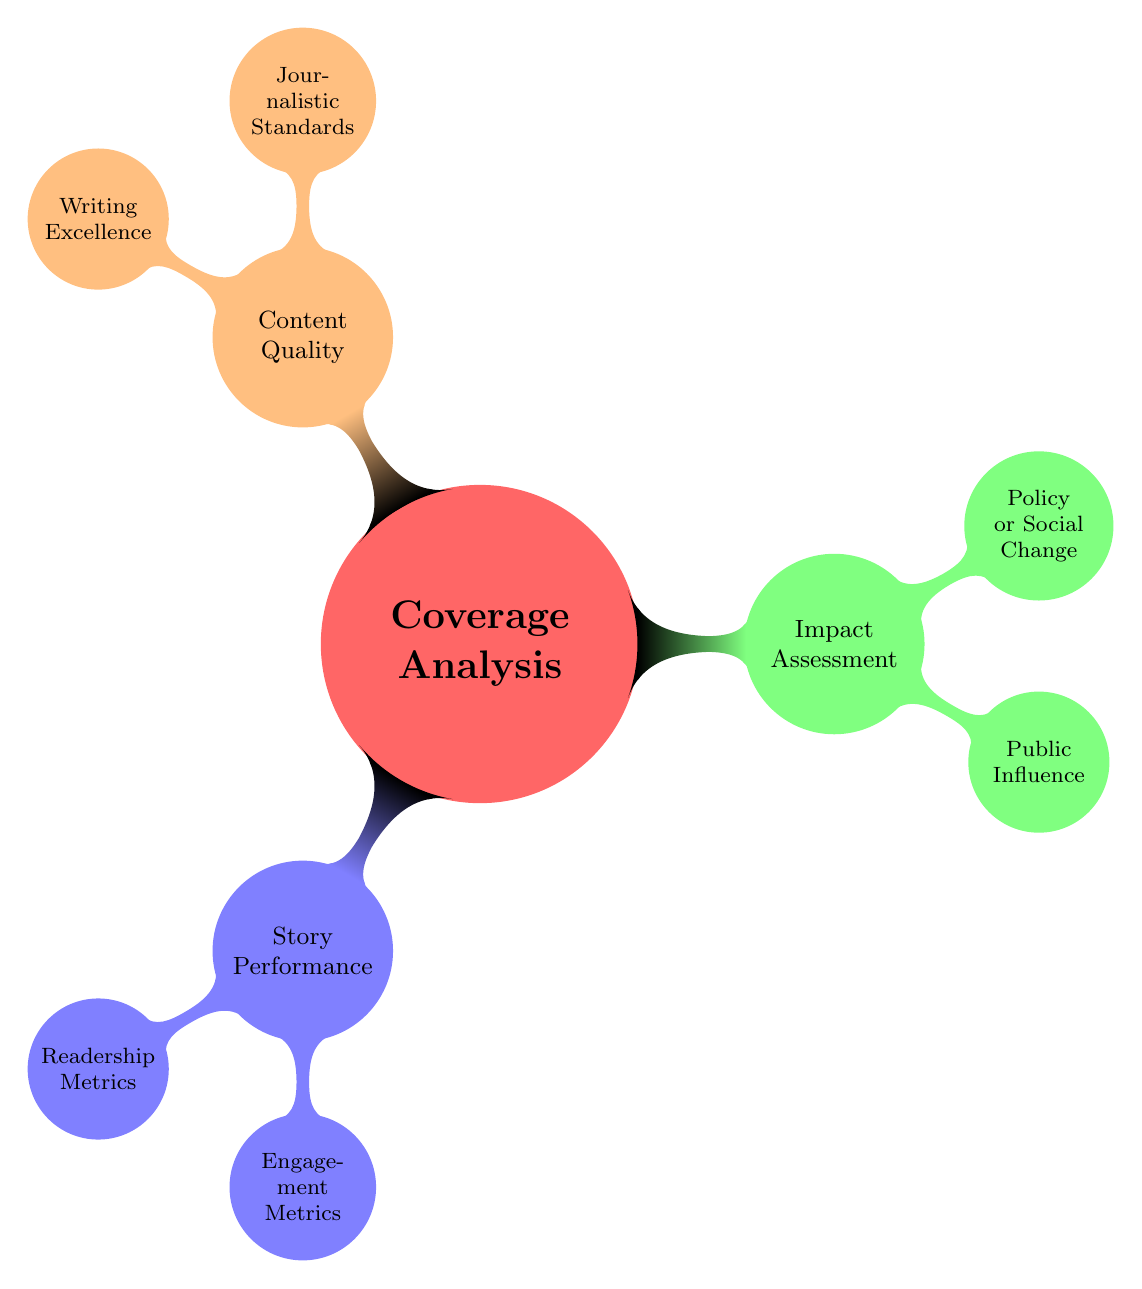What are the three main categories in the Coverage Analysis? The main categories are Story Performance, Impact Assessment, and Content Quality, which are the first level nodes branching from the Coverage Analysis node.
Answer: Story Performance, Impact Assessment, Content Quality How many nodes are under the Story Performance category? The Story Performance category has two child nodes: Readership Metrics and Engagement Metrics, making a total of two nodes under this category.
Answer: 2 What type of metrics are included in the Readership Metrics? The Readership Metrics include Page Views, Time on Page, and Bounce Rate, which are the specific metrics outlined under this category.
Answer: Page Views, Time on Page, Bounce Rate Which metrics are used to evaluate Social Shares? Social shares are evaluated using Facebook Insights and Twitter Analytics as indicated in the Engagement Metrics section of the diagram.
Answer: Facebook Insights, Twitter Analytics How does the Impact Assessment relate to Public Influence? The Impact Assessment contains a category called Public Influence, which explores metrics such as Mentions in Other Media and Citations in Research or Reports, indicating a direct relationship between them.
Answer: Public Influence includes Mentions in Other Media and Citations in Research or Reports What is the second level node under Content Quality? The second level nodes under Content Quality are Journalistic Standards and Writing Excellence, showing the aspects considered under content evaluation.
Answer: Journalistic Standards, Writing Excellence Which tools are mentioned for Fact-Checking in the Coverage Analysis? The tools mentioned for Fact-Checking are the Internal Fact-Checking Team, as specified in the Journalistic Standards section of the Content Quality category.
Answer: Internal Fact-Checking Team What is a metric that indicates reader engagement according to the diagram? A metric that indicates reader engagement is Comments, found under the Engagement Metrics section, showing a direct interaction with the audience.
Answer: Comments 